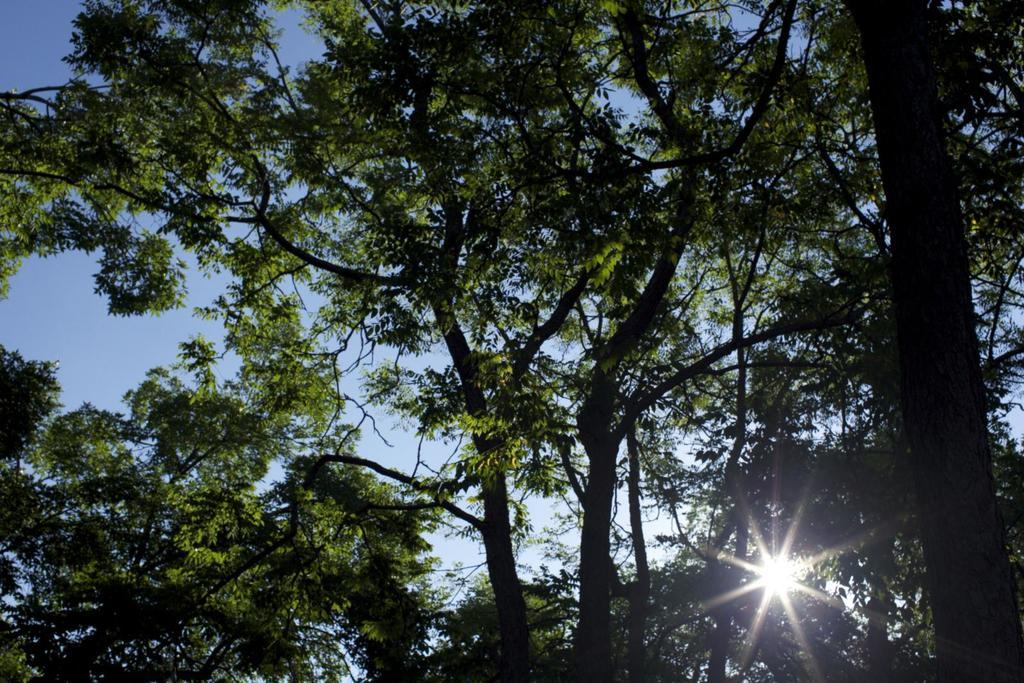What type of vegetation can be seen in the image? There are trees in the image. What part of the natural environment is visible in the image? The sky is visible in the image. What route does the tray take to reach the school in the image? There is no tray or school present in the image, so it is not possible to determine a route. 